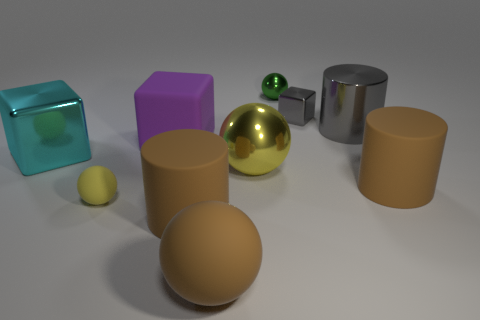Subtract all balls. How many objects are left? 6 Add 2 green metal objects. How many green metal objects are left? 3 Add 4 big brown rubber things. How many big brown rubber things exist? 7 Subtract 0 red balls. How many objects are left? 10 Subtract all cyan blocks. Subtract all shiny blocks. How many objects are left? 7 